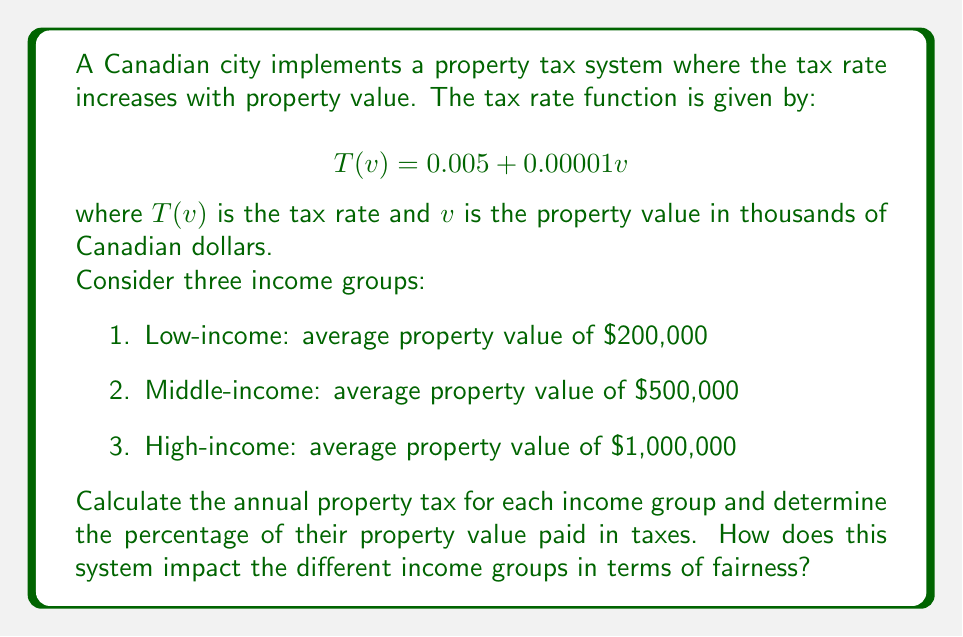Could you help me with this problem? To solve this problem, we'll follow these steps for each income group:

1. Calculate the tax rate using the given function
2. Calculate the annual property tax
3. Determine the percentage of property value paid in taxes

For the low-income group (property value = $200,000):
1. Tax rate: $T(200) = 0.005 + 0.00001(200) = 0.007$ or 0.7%
2. Annual property tax: $200,000 \times 0.007 = $1,400
3. Percentage of property value: $(1,400 / 200,000) \times 100\% = 0.7\%$

For the middle-income group (property value = $500,000):
1. Tax rate: $T(500) = 0.005 + 0.00001(500) = 0.01$ or 1%
2. Annual property tax: $500,000 \times 0.01 = $5,000
3. Percentage of property value: $(5,000 / 500,000) \times 100\% = 1\%$

For the high-income group (property value = $1,000,000):
1. Tax rate: $T(1000) = 0.005 + 0.00001(1000) = 0.015$ or 1.5%
2. Annual property tax: $1,000,000 \times 0.015 = $15,000
3. Percentage of property value: $(15,000 / 1,000,000) \times 100\% = 1.5\%$

Impact on fairness:
The progressive tax system results in higher-income groups paying a larger percentage of their property value in taxes. This could be seen as fair because it places a higher burden on those with more valuable properties and presumably higher incomes. However, it also means that as property values increase, the tax burden increases at a faster rate, which might be challenging for some homeowners if their incomes don't increase proportionally with their property values.
Answer: Low-income group: $1,400 annual tax (0.7% of property value)
Middle-income group: $5,000 annual tax (1% of property value)
High-income group: $15,000 annual tax (1.5% of property value)

The tax system is progressive, with higher-income groups paying a larger percentage of their property value in taxes, which could be seen as promoting fairness but may also create challenges for some homeowners. 